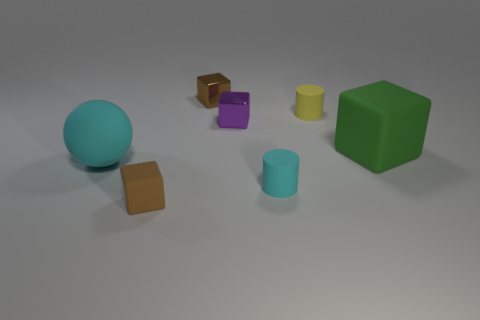Add 3 tiny purple metal cylinders. How many objects exist? 10 Subtract all spheres. How many objects are left? 6 Subtract 0 yellow spheres. How many objects are left? 7 Subtract all small blue shiny balls. Subtract all small brown metal cubes. How many objects are left? 6 Add 2 tiny brown metallic objects. How many tiny brown metallic objects are left? 3 Add 7 tiny cyan cylinders. How many tiny cyan cylinders exist? 8 